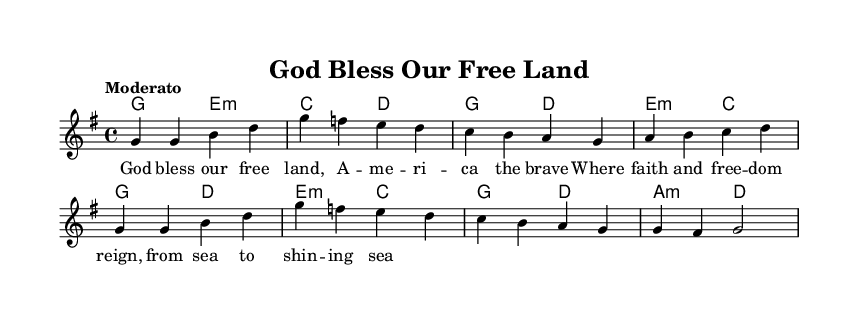What is the key signature of this music? The key signature shown is G major, which has one sharp indicated by the presence of an F sharp.
Answer: G major What is the time signature of this music? The time signature displayed is 4/4, meaning there are four beats per measure, and the quarter note gets one beat.
Answer: 4/4 What is the tempo marking for this music? The tempo marking is "Moderato," indicating a moderate speed for the piece.
Answer: Moderato How many measures are in this piece? By counting the measures in the melody and harmonies, there are a total of 8 measures present.
Answer: 8 What is the first note of the melody? The first note of the melody is G, which is indicated at the beginning of the score.
Answer: G What is the theme expressed in the lyrics? The theme expressed in the lyrics focuses on patriotism and religious freedom, as it mentions blessing the land and faith.
Answer: Patriotism What type of music is this? This music is classified as religious patriotic music, emphasizing themes of national pride and faith.
Answer: Religious patriotic 